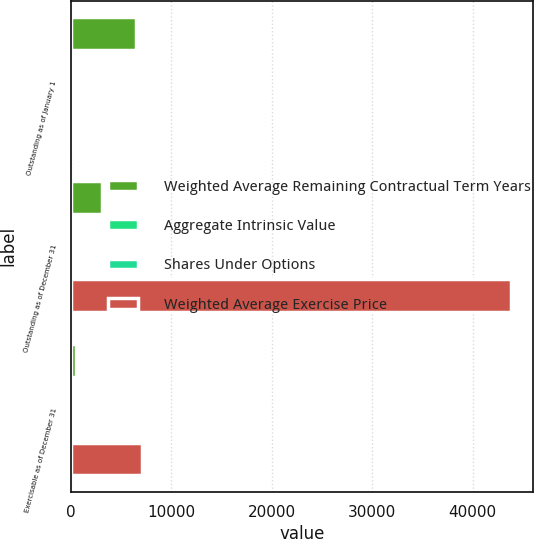<chart> <loc_0><loc_0><loc_500><loc_500><stacked_bar_chart><ecel><fcel>Outstanding as of January 1<fcel>Outstanding as of December 31<fcel>Exercisable as of December 31<nl><fcel>Weighted Average Remaining Contractual Term Years<fcel>6524<fcel>3127<fcel>539<nl><fcel>Aggregate Intrinsic Value<fcel>28.76<fcel>31.16<fcel>32.09<nl><fcel>Shares Under Options<fcel>6.1<fcel>6.9<fcel>6<nl><fcel>Weighted Average Exercise Price<fcel>32.09<fcel>43774<fcel>7041<nl></chart> 